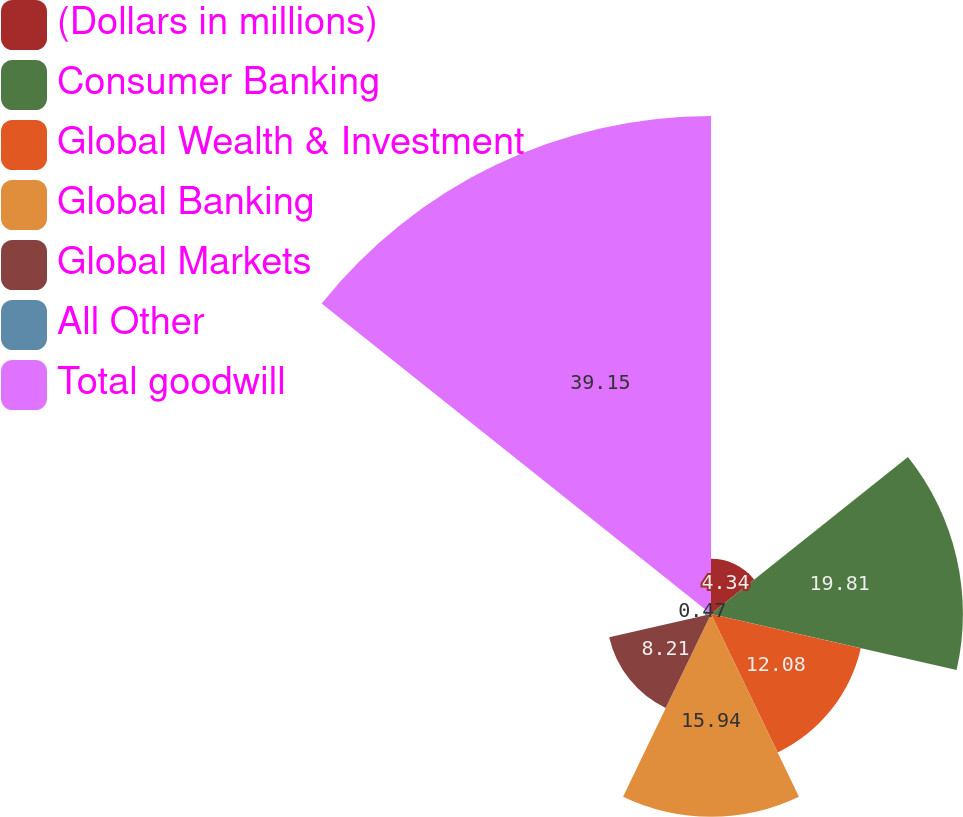Convert chart to OTSL. <chart><loc_0><loc_0><loc_500><loc_500><pie_chart><fcel>(Dollars in millions)<fcel>Consumer Banking<fcel>Global Wealth & Investment<fcel>Global Banking<fcel>Global Markets<fcel>All Other<fcel>Total goodwill<nl><fcel>4.34%<fcel>19.81%<fcel>12.08%<fcel>15.94%<fcel>8.21%<fcel>0.47%<fcel>39.16%<nl></chart> 